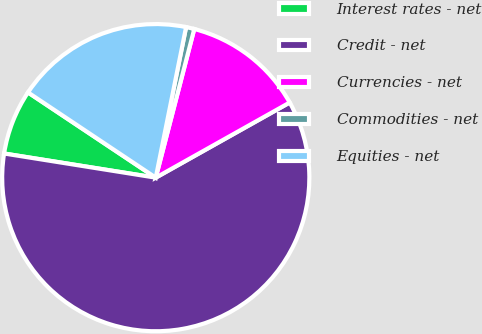Convert chart to OTSL. <chart><loc_0><loc_0><loc_500><loc_500><pie_chart><fcel>Interest rates - net<fcel>Credit - net<fcel>Currencies - net<fcel>Commodities - net<fcel>Equities - net<nl><fcel>6.85%<fcel>60.65%<fcel>12.83%<fcel>0.87%<fcel>18.8%<nl></chart> 